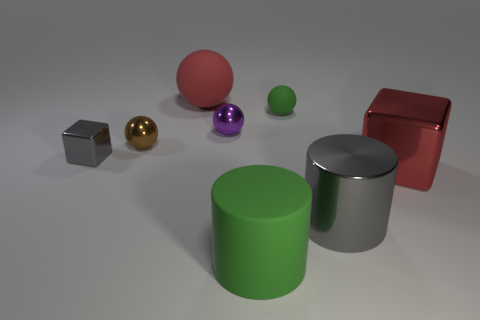How many things are either big gray matte balls or green rubber objects in front of the brown shiny ball?
Ensure brevity in your answer.  1. Are there more small brown things than large metallic things?
Your answer should be compact. No. There is a block that is the same color as the metallic cylinder; what is its size?
Your response must be concise. Small. Are there any tiny red cylinders that have the same material as the small gray block?
Your response must be concise. No. There is a thing that is behind the tiny purple metal ball and on the left side of the purple object; what shape is it?
Your answer should be compact. Sphere. How many other objects are the same shape as the brown object?
Offer a very short reply. 3. What is the size of the purple object?
Provide a short and direct response. Small. How many objects are yellow metal things or brown objects?
Give a very brief answer. 1. How big is the metal block left of the large red ball?
Keep it short and to the point. Small. Is there anything else that is the same size as the green cylinder?
Keep it short and to the point. Yes. 